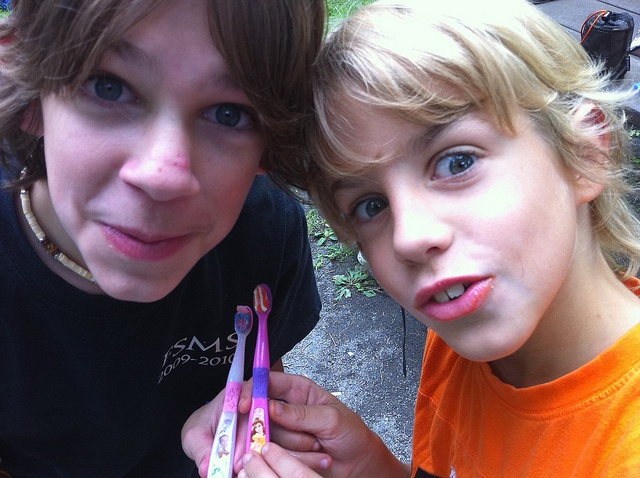Describe the objects in this image and their specific colors. I can see people in blue, lightgray, darkgray, and gray tones, people in blue, black, purple, and darkgray tones, toothbrush in blue, white, violet, and purple tones, and toothbrush in blue, violet, lavender, and purple tones in this image. 